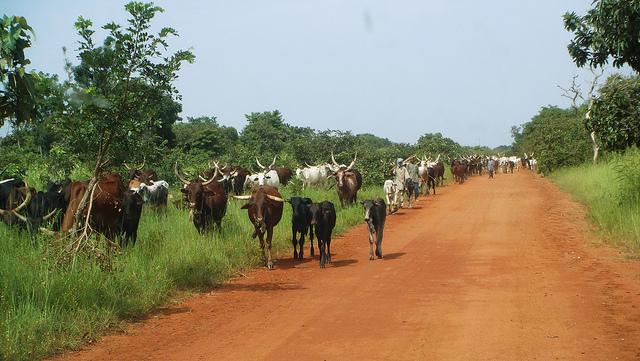What is the road made out of?
Write a very short answer. Dirt. How many different types of animals are present?
Write a very short answer. 3. How many people are walking next to the cows?
Concise answer only. 1. How many cows are on the left?
Keep it brief. All of them. Is there a person guiding these animals?
Short answer required. Yes. How many bulls are there?
Keep it brief. 15. 